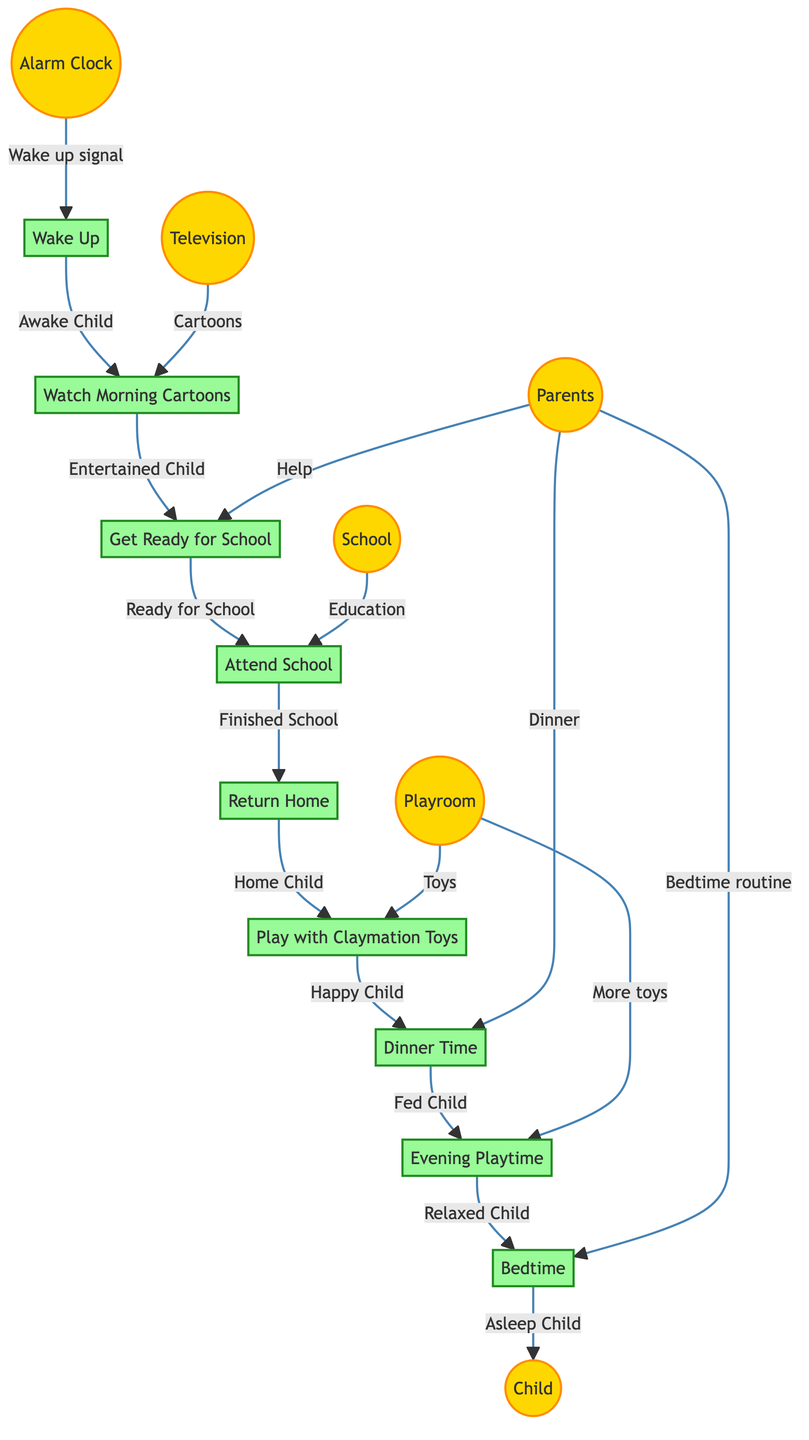What is the first process in the diagram? The diagram starts with the "Wake Up" process, which is labeled as number 1. This process follows the input from the "Alarm Clock" external entity.
Answer: Wake Up Who helps the child get ready for school? According to the diagram, the "Parents" external entity provide help in the "Get Ready for School" process.
Answer: Parents What signal triggers the child to wake up? The triggering signal for waking up is indicated as the "Wake up signal" from the "Alarm Clock" entity that connects to the "Wake Up" process.
Answer: Wake up signal How does the child feel after playing with claymation toys? The output of the "Play with Claymation Toys" process indicates the child feels "Happy" after engaging in this activity.
Answer: Happy Child What are the last two processes before the child sleeps? The last two processes before bedtime are "Evening Playtime," which leads to "Bedtime," as shown in sequence.
Answer: Evening Playtime and Bedtime Which process involves the external entity named "School"? The "Attend School" process directly involves the "School" external entity as an input to that process, highlighting the educational aspect.
Answer: Attend School How many main processes are represented in the diagram? By counting the numbered processes displayed in the diagram, there are a total of 9 main processes.
Answer: 9 What is the output of the "Dinner Time" process? The "Dinner Time" process results in the output labeled "Fed Child," indicating that the child has been fed after this activity.
Answer: Fed Child What connects the "Return Home" process to the "Play with Claymation Toys" process? The output of the "Return Home" process, which is "Home Child," serves as the input for the subsequent "Play with Claymation Toys" process, indicating a flow of information.
Answer: Home Child 